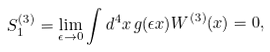Convert formula to latex. <formula><loc_0><loc_0><loc_500><loc_500>S ^ { ( 3 ) } _ { 1 } = \lim _ { \epsilon \to 0 } \int d ^ { 4 } x \, g ( \epsilon x ) W ^ { ( 3 ) } ( x ) = 0 ,</formula> 